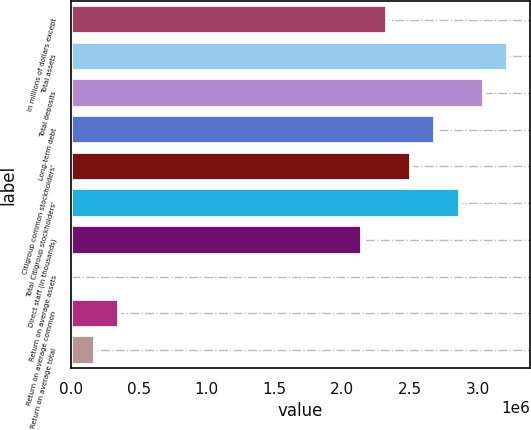<chart> <loc_0><loc_0><loc_500><loc_500><bar_chart><fcel>In millions of dollars except<fcel>Total assets<fcel>Total deposits<fcel>Long-term debt<fcel>Citigroup common stockholders'<fcel>Total Citigroup stockholders'<fcel>Direct staff (in thousands)<fcel>Return on average assets<fcel>Return on average common<fcel>Return on average total<nl><fcel>2.3297e+06<fcel>3.22574e+06<fcel>3.04653e+06<fcel>2.68812e+06<fcel>2.50891e+06<fcel>2.86732e+06<fcel>2.15049e+06<fcel>0.82<fcel>358416<fcel>179208<nl></chart> 